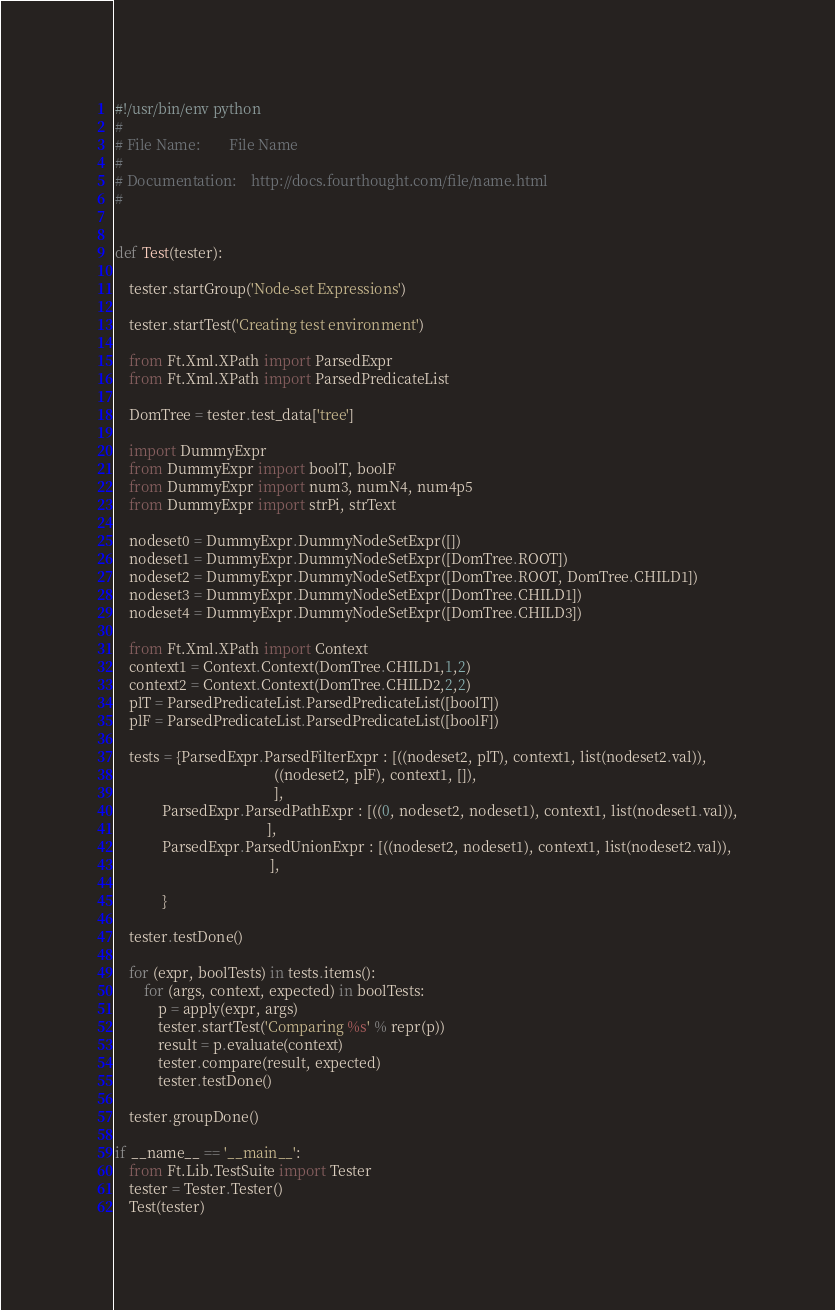Convert code to text. <code><loc_0><loc_0><loc_500><loc_500><_Python_>#!/usr/bin/env python
#
# File Name:        File Name
#
# Documentation:    http://docs.fourthought.com/file/name.html
#


def Test(tester):

    tester.startGroup('Node-set Expressions')

    tester.startTest('Creating test environment')

    from Ft.Xml.XPath import ParsedExpr
    from Ft.Xml.XPath import ParsedPredicateList

    DomTree = tester.test_data['tree']

    import DummyExpr
    from DummyExpr import boolT, boolF
    from DummyExpr import num3, numN4, num4p5
    from DummyExpr import strPi, strText
    
    nodeset0 = DummyExpr.DummyNodeSetExpr([])
    nodeset1 = DummyExpr.DummyNodeSetExpr([DomTree.ROOT])
    nodeset2 = DummyExpr.DummyNodeSetExpr([DomTree.ROOT, DomTree.CHILD1])
    nodeset3 = DummyExpr.DummyNodeSetExpr([DomTree.CHILD1])
    nodeset4 = DummyExpr.DummyNodeSetExpr([DomTree.CHILD3])

    from Ft.Xml.XPath import Context
    context1 = Context.Context(DomTree.CHILD1,1,2)
    context2 = Context.Context(DomTree.CHILD2,2,2)
    plT = ParsedPredicateList.ParsedPredicateList([boolT])
    plF = ParsedPredicateList.ParsedPredicateList([boolF])

    tests = {ParsedExpr.ParsedFilterExpr : [((nodeset2, plT), context1, list(nodeset2.val)),
                                            ((nodeset2, plF), context1, []),
                                            ],
             ParsedExpr.ParsedPathExpr : [((0, nodeset2, nodeset1), context1, list(nodeset1.val)),
                                          ],
             ParsedExpr.ParsedUnionExpr : [((nodeset2, nodeset1), context1, list(nodeset2.val)),
                                           ],

             }

    tester.testDone()

    for (expr, boolTests) in tests.items():
        for (args, context, expected) in boolTests:
            p = apply(expr, args)
            tester.startTest('Comparing %s' % repr(p))
            result = p.evaluate(context)
            tester.compare(result, expected)
            tester.testDone()

    tester.groupDone()

if __name__ == '__main__':
    from Ft.Lib.TestSuite import Tester
    tester = Tester.Tester()
    Test(tester)
</code> 